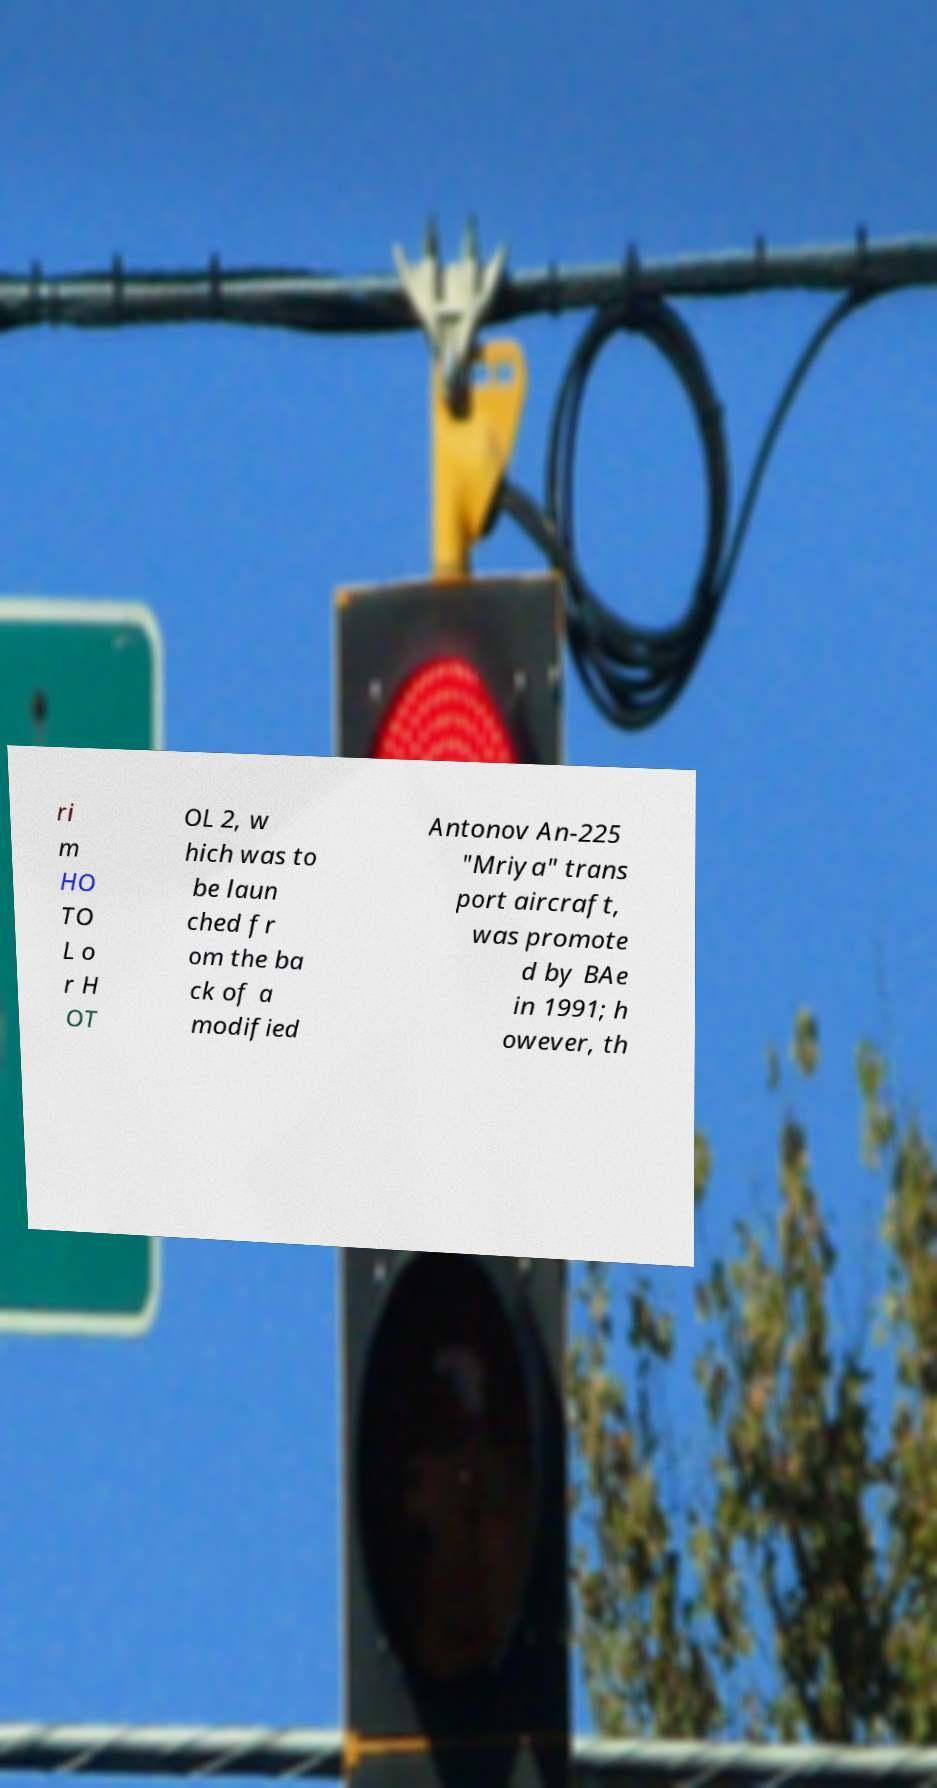There's text embedded in this image that I need extracted. Can you transcribe it verbatim? ri m HO TO L o r H OT OL 2, w hich was to be laun ched fr om the ba ck of a modified Antonov An-225 "Mriya" trans port aircraft, was promote d by BAe in 1991; h owever, th 